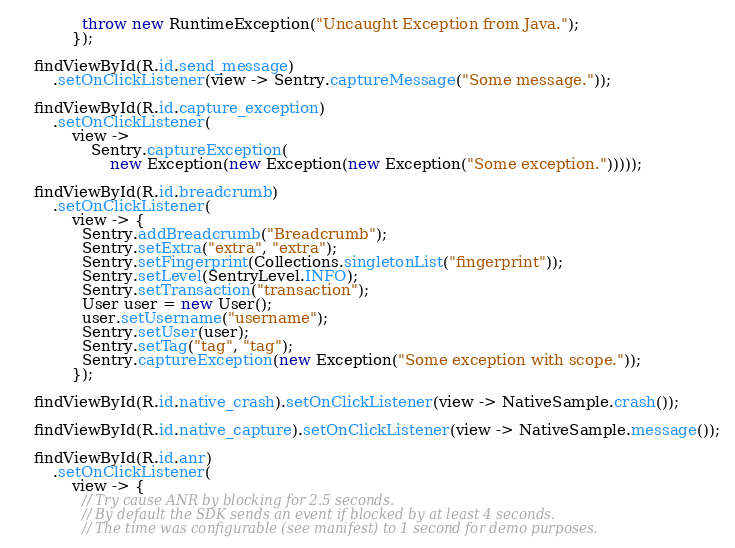Convert code to text. <code><loc_0><loc_0><loc_500><loc_500><_Java_>              throw new RuntimeException("Uncaught Exception from Java.");
            });

    findViewById(R.id.send_message)
        .setOnClickListener(view -> Sentry.captureMessage("Some message."));

    findViewById(R.id.capture_exception)
        .setOnClickListener(
            view ->
                Sentry.captureException(
                    new Exception(new Exception(new Exception("Some exception.")))));

    findViewById(R.id.breadcrumb)
        .setOnClickListener(
            view -> {
              Sentry.addBreadcrumb("Breadcrumb");
              Sentry.setExtra("extra", "extra");
              Sentry.setFingerprint(Collections.singletonList("fingerprint"));
              Sentry.setLevel(SentryLevel.INFO);
              Sentry.setTransaction("transaction");
              User user = new User();
              user.setUsername("username");
              Sentry.setUser(user);
              Sentry.setTag("tag", "tag");
              Sentry.captureException(new Exception("Some exception with scope."));
            });

    findViewById(R.id.native_crash).setOnClickListener(view -> NativeSample.crash());

    findViewById(R.id.native_capture).setOnClickListener(view -> NativeSample.message());

    findViewById(R.id.anr)
        .setOnClickListener(
            view -> {
              // Try cause ANR by blocking for 2.5 seconds.
              // By default the SDK sends an event if blocked by at least 4 seconds.
              // The time was configurable (see manifest) to 1 second for demo purposes.</code> 